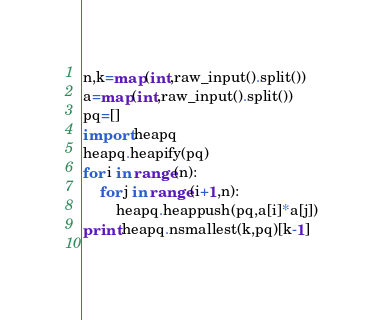<code> <loc_0><loc_0><loc_500><loc_500><_Python_>n,k=map(int,raw_input().split())
a=map(int,raw_input().split())
pq=[]
import heapq
heapq.heapify(pq)
for i in range(n):
    for j in range(i+1,n):
        heapq.heappush(pq,a[i]*a[j])
print heapq.nsmallest(k,pq)[k-1]
    </code> 